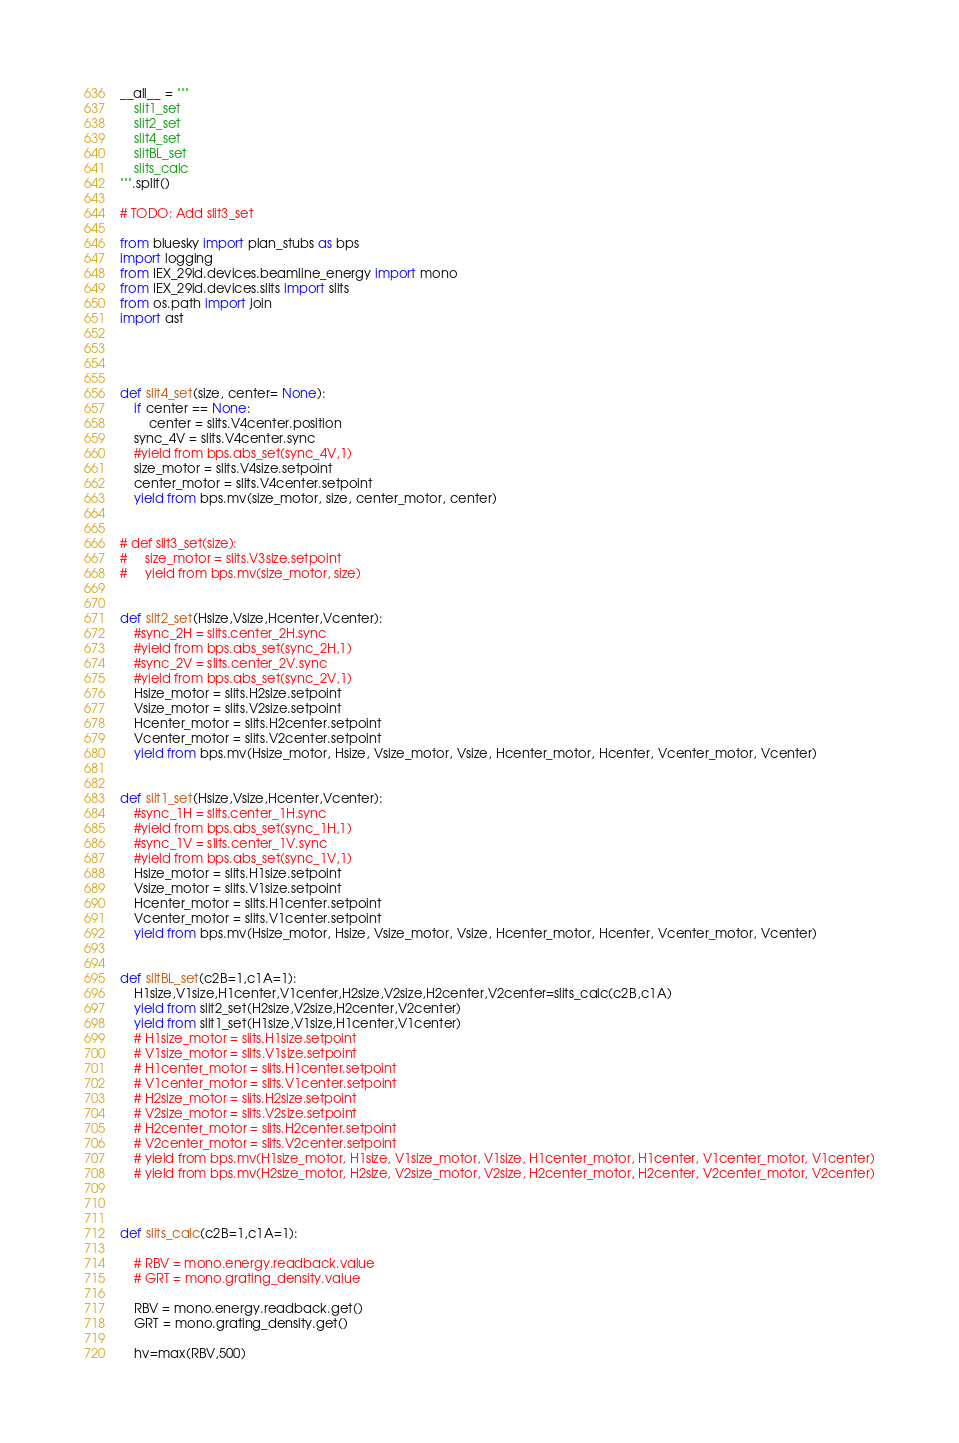Convert code to text. <code><loc_0><loc_0><loc_500><loc_500><_Python_>
__all__ = """
    slit1_set
    slit2_set
    slit4_set
    slitBL_set
    slits_calc
""".split()

# TODO: Add slit3_set

from bluesky import plan_stubs as bps
import logging
from IEX_29id.devices.beamline_energy import mono
from IEX_29id.devices.slits import slits
from os.path import join
import ast




def slit4_set(size, center= None):
    if center == None:
        center = slits.V4center.position
    sync_4V = slits.V4center.sync
    #yield from bps.abs_set(sync_4V,1)
    size_motor = slits.V4size.setpoint
    center_motor = slits.V4center.setpoint
    yield from bps.mv(size_motor, size, center_motor, center)
    
    
# def slit3_set(size):
#     size_motor = slits.V3size.setpoint
#     yield from bps.mv(size_motor, size)    
    
    
def slit2_set(Hsize,Vsize,Hcenter,Vcenter):
    #sync_2H = slits.center_2H.sync
    #yield from bps.abs_set(sync_2H,1)
    #sync_2V = slits.center_2V.sync
    #yield from bps.abs_set(sync_2V,1)
    Hsize_motor = slits.H2size.setpoint
    Vsize_motor = slits.V2size.setpoint
    Hcenter_motor = slits.H2center.setpoint
    Vcenter_motor = slits.V2center.setpoint
    yield from bps.mv(Hsize_motor, Hsize, Vsize_motor, Vsize, Hcenter_motor, Hcenter, Vcenter_motor, Vcenter)
    
    
def slit1_set(Hsize,Vsize,Hcenter,Vcenter):
    #sync_1H = slits.center_1H.sync
    #yield from bps.abs_set(sync_1H,1)
    #sync_1V = slits.center_1V.sync
    #yield from bps.abs_set(sync_1V,1)
    Hsize_motor = slits.H1size.setpoint
    Vsize_motor = slits.V1size.setpoint
    Hcenter_motor = slits.H1center.setpoint
    Vcenter_motor = slits.V1center.setpoint
    yield from bps.mv(Hsize_motor, Hsize, Vsize_motor, Vsize, Hcenter_motor, Hcenter, Vcenter_motor, Vcenter)
    

def slitBL_set(c2B=1,c1A=1):
    H1size,V1size,H1center,V1center,H2size,V2size,H2center,V2center=slits_calc(c2B,c1A)
    yield from slit2_set(H2size,V2size,H2center,V2center)
    yield from slit1_set(H1size,V1size,H1center,V1center)
    # H1size_motor = slits.H1size.setpoint
    # V1size_motor = slits.V1size.setpoint
    # H1center_motor = slits.H1center.setpoint
    # V1center_motor = slits.V1center.setpoint
    # H2size_motor = slits.H2size.setpoint
    # V2size_motor = slits.V2size.setpoint
    # H2center_motor = slits.H2center.setpoint
    # V2center_motor = slits.V2center.setpoint
    # yield from bps.mv(H1size_motor, H1size, V1size_motor, V1size, H1center_motor, H1center, V1center_motor, V1center)
    # yield from bps.mv(H2size_motor, H2size, V2size_motor, V2size, H2center_motor, H2center, V2center_motor, V2center)
    

    
def slits_calc(c2B=1,c1A=1):

    # RBV = mono.energy.readback.value
    # GRT = mono.grating_density.value

    RBV = mono.energy.readback.get()
    GRT = mono.grating_density.get()
    
    hv=max(RBV,500)</code> 